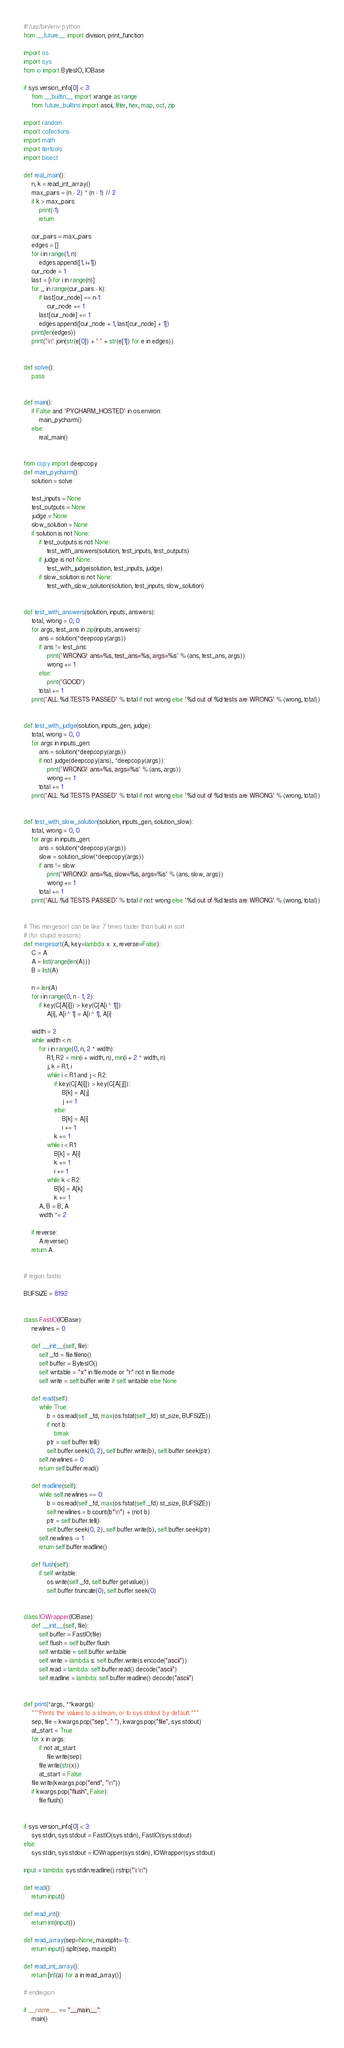Convert code to text. <code><loc_0><loc_0><loc_500><loc_500><_Python_>#!/usr/bin/env python
from __future__ import division, print_function

import os
import sys
from io import BytesIO, IOBase

if sys.version_info[0] < 3:
    from __builtin__ import xrange as range
    from future_builtins import ascii, filter, hex, map, oct, zip

import random
import collections
import math
import itertools
import bisect

def real_main():
    n, k = read_int_array()
    max_pairs = (n - 2) * (n - 1) // 2
    if k > max_pairs:
        print(-1)
        return

    cur_pairs = max_pairs
    edges = []
    for i in range(1, n):
        edges.append([1, i+1])
    cur_node = 1
    last = [i for i in range(n)]
    for _ in range(cur_pairs - k):
        if last[cur_node] == n-1:
            cur_node += 1
        last[cur_node] += 1
        edges.append([cur_node + 1, last[cur_node] + 1])
    print(len(edges))
    print('\n'.join(str(e[0]) + ' ' + str(e[1]) for e in edges))


def solve():
    pass


def main():
    if False and 'PYCHARM_HOSTED' in os.environ:
        main_pycharm()
    else:
        real_main()


from copy import deepcopy
def main_pycharm():
    solution = solve

    test_inputs = None
    test_outputs = None
    judge = None
    slow_solution = None
    if solution is not None:
        if test_outputs is not None:
            test_with_answers(solution, test_inputs, test_outputs)
        if judge is not None:
            test_with_judge(solution, test_inputs, judge)
        if slow_solution is not None:
            test_with_slow_solution(solution, test_inputs, slow_solution)


def test_with_answers(solution, inputs, answers):
    total, wrong = 0, 0
    for args, test_ans in zip(inputs, answers):
        ans = solution(*deepcopy(args))
        if ans != test_ans:
            print('WRONG! ans=%s, test_ans=%s, args=%s' % (ans, test_ans, args))
            wrong += 1
        else:
            print('GOOD')
        total += 1
    print('ALL %d TESTS PASSED' % total if not wrong else '%d out of %d tests are WRONG' % (wrong, total))


def test_with_judge(solution, inputs_gen, judge):
    total, wrong = 0, 0
    for args in inputs_gen:
        ans = solution(*deepcopy(args))
        if not judge(deepcopy(ans), *deepcopy(args)):
            print('WRONG! ans=%s, args=%s' % (ans, args))
            wrong += 1
        total += 1
    print('ALL %d TESTS PASSED' % total if not wrong else '%d out of %d tests are WRONG' % (wrong, total))


def test_with_slow_solution(solution, inputs_gen, solution_slow):
    total, wrong = 0, 0
    for args in inputs_gen:
        ans = solution(*deepcopy(args))
        slow = solution_slow(*deepcopy(args))
        if ans != slow:
            print('WRONG! ans=%s, slow=%s, args=%s' % (ans, slow, args))
            wrong += 1
        total += 1
    print('ALL %d TESTS PASSED' % total if not wrong else '%d out of %d tests are WRONG' % (wrong, total))


# This mergesort can be like 7 times faster than build in sort
# (for stupid reasons)
def mergesort(A, key=lambda x: x, reverse=False):
    C = A
    A = list(range(len(A)))
    B = list(A)

    n = len(A)
    for i in range(0, n - 1, 2):
        if key(C[A[i]]) > key(C[A[i ^ 1]]):
            A[i], A[i ^ 1] = A[i ^ 1], A[i]

    width = 2
    while width < n:
        for i in range(0, n, 2 * width):
            R1, R2 = min(i + width, n), min(i + 2 * width, n)
            j, k = R1, i
            while i < R1 and j < R2:
                if key(C[A[i]]) > key(C[A[j]]):
                    B[k] = A[j]
                    j += 1
                else:
                    B[k] = A[i]
                    i += 1
                k += 1
            while i < R1:
                B[k] = A[i]
                k += 1
                i += 1
            while k < R2:
                B[k] = A[k]
                k += 1
        A, B = B, A
        width *= 2

    if reverse:
        A.reverse()
    return A


# region fastio

BUFSIZE = 8192


class FastIO(IOBase):
    newlines = 0

    def __init__(self, file):
        self._fd = file.fileno()
        self.buffer = BytesIO()
        self.writable = "x" in file.mode or "r" not in file.mode
        self.write = self.buffer.write if self.writable else None

    def read(self):
        while True:
            b = os.read(self._fd, max(os.fstat(self._fd).st_size, BUFSIZE))
            if not b:
                break
            ptr = self.buffer.tell()
            self.buffer.seek(0, 2), self.buffer.write(b), self.buffer.seek(ptr)
        self.newlines = 0
        return self.buffer.read()

    def readline(self):
        while self.newlines == 0:
            b = os.read(self._fd, max(os.fstat(self._fd).st_size, BUFSIZE))
            self.newlines = b.count(b"\n") + (not b)
            ptr = self.buffer.tell()
            self.buffer.seek(0, 2), self.buffer.write(b), self.buffer.seek(ptr)
        self.newlines -= 1
        return self.buffer.readline()

    def flush(self):
        if self.writable:
            os.write(self._fd, self.buffer.getvalue())
            self.buffer.truncate(0), self.buffer.seek(0)


class IOWrapper(IOBase):
    def __init__(self, file):
        self.buffer = FastIO(file)
        self.flush = self.buffer.flush
        self.writable = self.buffer.writable
        self.write = lambda s: self.buffer.write(s.encode("ascii"))
        self.read = lambda: self.buffer.read().decode("ascii")
        self.readline = lambda: self.buffer.readline().decode("ascii")


def print(*args, **kwargs):
    """Prints the values to a stream, or to sys.stdout by default."""
    sep, file = kwargs.pop("sep", " "), kwargs.pop("file", sys.stdout)
    at_start = True
    for x in args:
        if not at_start:
            file.write(sep)
        file.write(str(x))
        at_start = False
    file.write(kwargs.pop("end", "\n"))
    if kwargs.pop("flush", False):
        file.flush()


if sys.version_info[0] < 3:
    sys.stdin, sys.stdout = FastIO(sys.stdin), FastIO(sys.stdout)
else:
    sys.stdin, sys.stdout = IOWrapper(sys.stdin), IOWrapper(sys.stdout)

input = lambda: sys.stdin.readline().rstrip("\r\n")

def read():
    return input()

def read_int():
    return int(input())

def read_array(sep=None, maxsplit=-1):
    return input().split(sep, maxsplit)

def read_int_array():
    return [int(a) for a in read_array()]

# endregion

if __name__ == "__main__":
    main()
</code> 